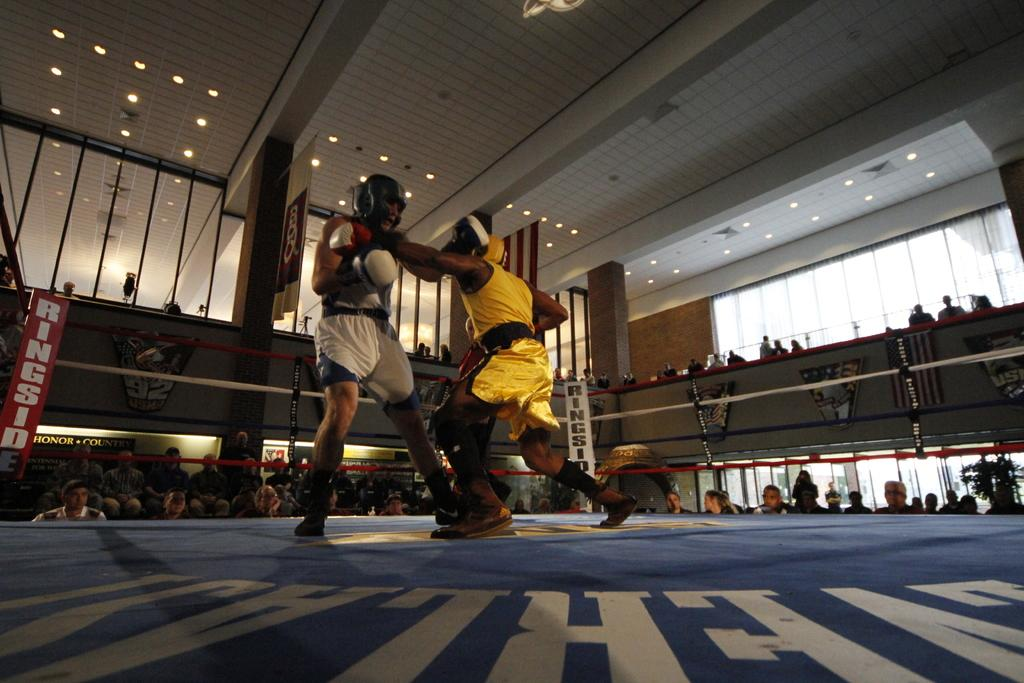<image>
Relay a brief, clear account of the picture shown. Ringside is shown on the corner posts of this boxing ring. 